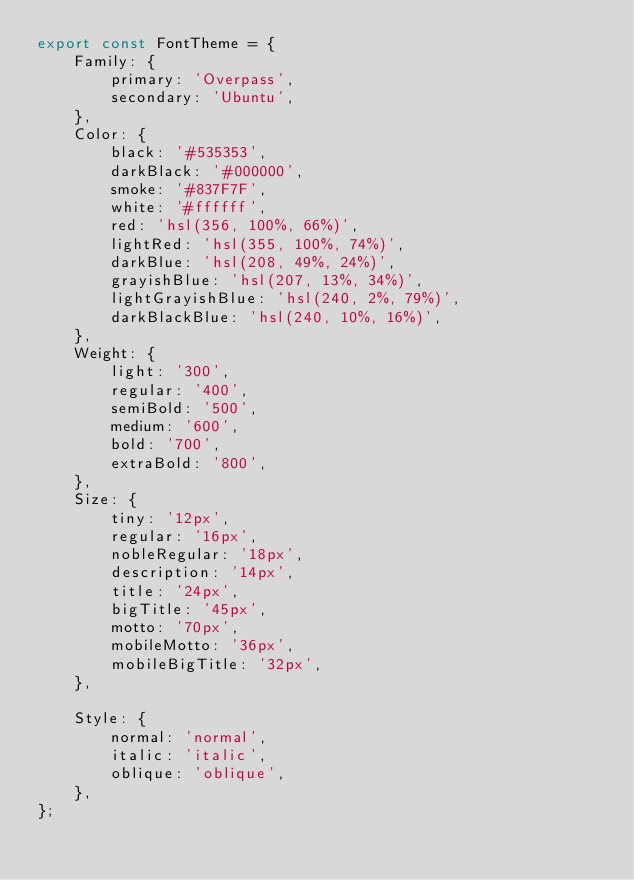<code> <loc_0><loc_0><loc_500><loc_500><_JavaScript_>export const FontTheme = {
    Family: {
        primary: 'Overpass',
        secondary: 'Ubuntu',
    },
    Color: {
        black: '#535353',
        darkBlack: '#000000',
        smoke: '#837F7F',
        white: '#ffffff',
        red: 'hsl(356, 100%, 66%)',
        lightRed: 'hsl(355, 100%, 74%)',
        darkBlue: 'hsl(208, 49%, 24%)',
        grayishBlue: 'hsl(207, 13%, 34%)',
        lightGrayishBlue: 'hsl(240, 2%, 79%)',
        darkBlackBlue: 'hsl(240, 10%, 16%)',
    },
    Weight: {
        light: '300',
        regular: '400',
        semiBold: '500',
        medium: '600',
        bold: '700',
        extraBold: '800',
    },
    Size: {
        tiny: '12px',
        regular: '16px',
        nobleRegular: '18px',
        description: '14px',
        title: '24px',
        bigTitle: '45px',
        motto: '70px',
        mobileMotto: '36px',
        mobileBigTitle: '32px',
    },

    Style: {
        normal: 'normal',
        italic: 'italic',
        oblique: 'oblique',
    },
};
</code> 